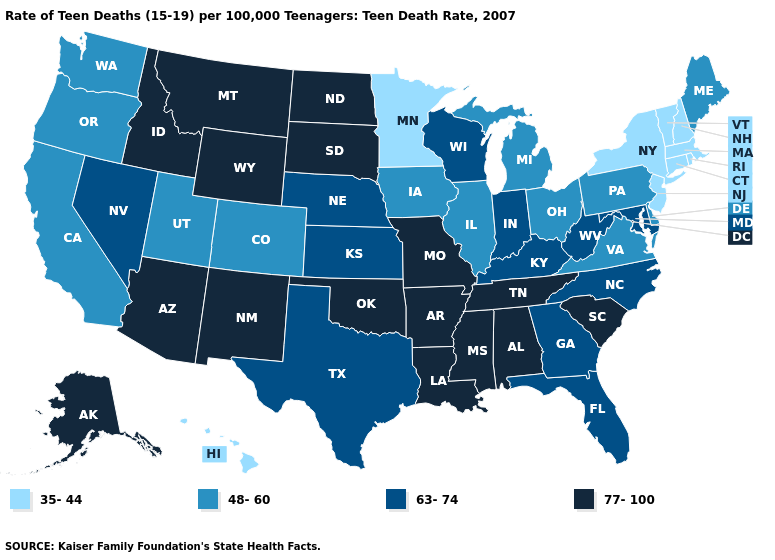Does Delaware have the same value as Pennsylvania?
Keep it brief. Yes. Among the states that border Ohio , does Pennsylvania have the lowest value?
Keep it brief. Yes. What is the value of Maryland?
Answer briefly. 63-74. What is the value of Tennessee?
Give a very brief answer. 77-100. What is the lowest value in states that border Nebraska?
Keep it brief. 48-60. Does Minnesota have a lower value than Tennessee?
Concise answer only. Yes. Does the map have missing data?
Concise answer only. No. Name the states that have a value in the range 63-74?
Keep it brief. Florida, Georgia, Indiana, Kansas, Kentucky, Maryland, Nebraska, Nevada, North Carolina, Texas, West Virginia, Wisconsin. What is the value of Arkansas?
Keep it brief. 77-100. Does the map have missing data?
Keep it brief. No. Which states have the lowest value in the USA?
Quick response, please. Connecticut, Hawaii, Massachusetts, Minnesota, New Hampshire, New Jersey, New York, Rhode Island, Vermont. What is the value of Washington?
Give a very brief answer. 48-60. What is the value of Minnesota?
Short answer required. 35-44. Does New Mexico have the lowest value in the West?
Quick response, please. No. What is the highest value in the USA?
Keep it brief. 77-100. 